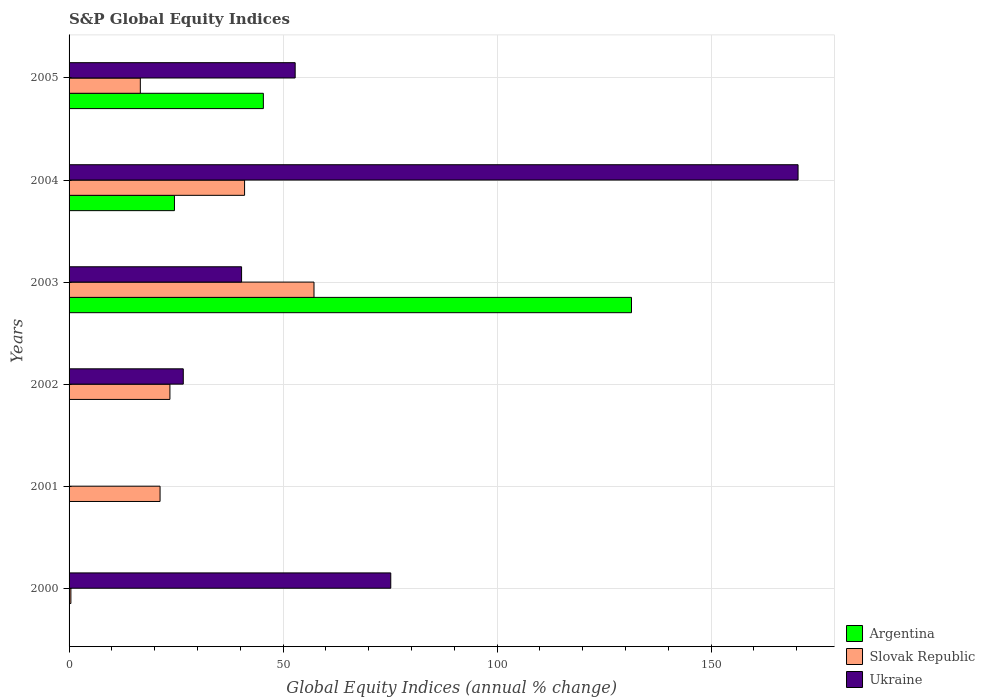How many different coloured bars are there?
Provide a succinct answer. 3. Are the number of bars on each tick of the Y-axis equal?
Offer a terse response. No. How many bars are there on the 5th tick from the top?
Your answer should be very brief. 1. In how many cases, is the number of bars for a given year not equal to the number of legend labels?
Your response must be concise. 3. What is the global equity indices in Ukraine in 2005?
Your answer should be very brief. 52.82. Across all years, what is the maximum global equity indices in Argentina?
Make the answer very short. 131.39. Across all years, what is the minimum global equity indices in Argentina?
Give a very brief answer. 0. In which year was the global equity indices in Slovak Republic maximum?
Provide a short and direct response. 2003. What is the total global equity indices in Ukraine in the graph?
Offer a terse response. 365.25. What is the difference between the global equity indices in Ukraine in 2004 and that in 2005?
Your response must be concise. 117.48. What is the difference between the global equity indices in Ukraine in 2005 and the global equity indices in Slovak Republic in 2002?
Your answer should be compact. 29.26. What is the average global equity indices in Argentina per year?
Keep it short and to the point. 33.57. In the year 2002, what is the difference between the global equity indices in Slovak Republic and global equity indices in Ukraine?
Offer a very short reply. -3.12. What is the ratio of the global equity indices in Ukraine in 2000 to that in 2005?
Keep it short and to the point. 1.42. Is the global equity indices in Ukraine in 2002 less than that in 2004?
Make the answer very short. Yes. What is the difference between the highest and the second highest global equity indices in Slovak Republic?
Offer a very short reply. 16.22. What is the difference between the highest and the lowest global equity indices in Argentina?
Give a very brief answer. 131.39. Is it the case that in every year, the sum of the global equity indices in Slovak Republic and global equity indices in Argentina is greater than the global equity indices in Ukraine?
Provide a short and direct response. No. How many bars are there?
Offer a terse response. 14. Are all the bars in the graph horizontal?
Provide a succinct answer. Yes. How many years are there in the graph?
Provide a short and direct response. 6. Does the graph contain grids?
Your answer should be very brief. Yes. Where does the legend appear in the graph?
Your answer should be compact. Bottom right. What is the title of the graph?
Offer a terse response. S&P Global Equity Indices. What is the label or title of the X-axis?
Keep it short and to the point. Global Equity Indices (annual % change). What is the label or title of the Y-axis?
Provide a succinct answer. Years. What is the Global Equity Indices (annual % change) in Slovak Republic in 2000?
Ensure brevity in your answer.  0.42. What is the Global Equity Indices (annual % change) in Ukraine in 2000?
Your answer should be compact. 75.15. What is the Global Equity Indices (annual % change) of Argentina in 2001?
Make the answer very short. 0. What is the Global Equity Indices (annual % change) of Slovak Republic in 2001?
Make the answer very short. 21.26. What is the Global Equity Indices (annual % change) in Ukraine in 2001?
Keep it short and to the point. 0. What is the Global Equity Indices (annual % change) in Argentina in 2002?
Your answer should be compact. 0. What is the Global Equity Indices (annual % change) in Slovak Republic in 2002?
Give a very brief answer. 23.56. What is the Global Equity Indices (annual % change) of Ukraine in 2002?
Your response must be concise. 26.68. What is the Global Equity Indices (annual % change) of Argentina in 2003?
Make the answer very short. 131.39. What is the Global Equity Indices (annual % change) in Slovak Republic in 2003?
Offer a very short reply. 57.22. What is the Global Equity Indices (annual % change) of Ukraine in 2003?
Provide a succinct answer. 40.3. What is the Global Equity Indices (annual % change) of Argentina in 2004?
Offer a very short reply. 24.62. What is the Global Equity Indices (annual % change) of Ukraine in 2004?
Your response must be concise. 170.3. What is the Global Equity Indices (annual % change) of Argentina in 2005?
Ensure brevity in your answer.  45.39. What is the Global Equity Indices (annual % change) of Slovak Republic in 2005?
Offer a very short reply. 16.65. What is the Global Equity Indices (annual % change) in Ukraine in 2005?
Your answer should be very brief. 52.82. Across all years, what is the maximum Global Equity Indices (annual % change) of Argentina?
Keep it short and to the point. 131.39. Across all years, what is the maximum Global Equity Indices (annual % change) in Slovak Republic?
Your response must be concise. 57.22. Across all years, what is the maximum Global Equity Indices (annual % change) in Ukraine?
Provide a succinct answer. 170.3. Across all years, what is the minimum Global Equity Indices (annual % change) of Argentina?
Offer a terse response. 0. Across all years, what is the minimum Global Equity Indices (annual % change) in Slovak Republic?
Your answer should be very brief. 0.42. Across all years, what is the minimum Global Equity Indices (annual % change) in Ukraine?
Give a very brief answer. 0. What is the total Global Equity Indices (annual % change) of Argentina in the graph?
Your answer should be compact. 201.4. What is the total Global Equity Indices (annual % change) of Slovak Republic in the graph?
Provide a succinct answer. 160.11. What is the total Global Equity Indices (annual % change) in Ukraine in the graph?
Your answer should be very brief. 365.25. What is the difference between the Global Equity Indices (annual % change) of Slovak Republic in 2000 and that in 2001?
Offer a terse response. -20.83. What is the difference between the Global Equity Indices (annual % change) in Slovak Republic in 2000 and that in 2002?
Offer a very short reply. -23.14. What is the difference between the Global Equity Indices (annual % change) of Ukraine in 2000 and that in 2002?
Your response must be concise. 48.47. What is the difference between the Global Equity Indices (annual % change) of Slovak Republic in 2000 and that in 2003?
Ensure brevity in your answer.  -56.8. What is the difference between the Global Equity Indices (annual % change) of Ukraine in 2000 and that in 2003?
Your response must be concise. 34.85. What is the difference between the Global Equity Indices (annual % change) of Slovak Republic in 2000 and that in 2004?
Your answer should be very brief. -40.58. What is the difference between the Global Equity Indices (annual % change) of Ukraine in 2000 and that in 2004?
Provide a succinct answer. -95.15. What is the difference between the Global Equity Indices (annual % change) of Slovak Republic in 2000 and that in 2005?
Offer a terse response. -16.22. What is the difference between the Global Equity Indices (annual % change) of Ukraine in 2000 and that in 2005?
Your answer should be very brief. 22.33. What is the difference between the Global Equity Indices (annual % change) in Slovak Republic in 2001 and that in 2002?
Keep it short and to the point. -2.3. What is the difference between the Global Equity Indices (annual % change) of Slovak Republic in 2001 and that in 2003?
Provide a succinct answer. -35.96. What is the difference between the Global Equity Indices (annual % change) of Slovak Republic in 2001 and that in 2004?
Offer a terse response. -19.74. What is the difference between the Global Equity Indices (annual % change) in Slovak Republic in 2001 and that in 2005?
Give a very brief answer. 4.61. What is the difference between the Global Equity Indices (annual % change) of Slovak Republic in 2002 and that in 2003?
Provide a succinct answer. -33.66. What is the difference between the Global Equity Indices (annual % change) in Ukraine in 2002 and that in 2003?
Your answer should be very brief. -13.62. What is the difference between the Global Equity Indices (annual % change) in Slovak Republic in 2002 and that in 2004?
Ensure brevity in your answer.  -17.44. What is the difference between the Global Equity Indices (annual % change) in Ukraine in 2002 and that in 2004?
Your response must be concise. -143.62. What is the difference between the Global Equity Indices (annual % change) of Slovak Republic in 2002 and that in 2005?
Ensure brevity in your answer.  6.91. What is the difference between the Global Equity Indices (annual % change) in Ukraine in 2002 and that in 2005?
Keep it short and to the point. -26.14. What is the difference between the Global Equity Indices (annual % change) of Argentina in 2003 and that in 2004?
Keep it short and to the point. 106.77. What is the difference between the Global Equity Indices (annual % change) of Slovak Republic in 2003 and that in 2004?
Ensure brevity in your answer.  16.22. What is the difference between the Global Equity Indices (annual % change) of Ukraine in 2003 and that in 2004?
Your answer should be compact. -130. What is the difference between the Global Equity Indices (annual % change) in Argentina in 2003 and that in 2005?
Ensure brevity in your answer.  86. What is the difference between the Global Equity Indices (annual % change) of Slovak Republic in 2003 and that in 2005?
Your response must be concise. 40.57. What is the difference between the Global Equity Indices (annual % change) in Ukraine in 2003 and that in 2005?
Give a very brief answer. -12.52. What is the difference between the Global Equity Indices (annual % change) in Argentina in 2004 and that in 2005?
Provide a succinct answer. -20.77. What is the difference between the Global Equity Indices (annual % change) in Slovak Republic in 2004 and that in 2005?
Provide a short and direct response. 24.35. What is the difference between the Global Equity Indices (annual % change) of Ukraine in 2004 and that in 2005?
Make the answer very short. 117.48. What is the difference between the Global Equity Indices (annual % change) of Slovak Republic in 2000 and the Global Equity Indices (annual % change) of Ukraine in 2002?
Keep it short and to the point. -26.26. What is the difference between the Global Equity Indices (annual % change) in Slovak Republic in 2000 and the Global Equity Indices (annual % change) in Ukraine in 2003?
Offer a very short reply. -39.88. What is the difference between the Global Equity Indices (annual % change) of Slovak Republic in 2000 and the Global Equity Indices (annual % change) of Ukraine in 2004?
Ensure brevity in your answer.  -169.88. What is the difference between the Global Equity Indices (annual % change) in Slovak Republic in 2000 and the Global Equity Indices (annual % change) in Ukraine in 2005?
Your response must be concise. -52.4. What is the difference between the Global Equity Indices (annual % change) of Slovak Republic in 2001 and the Global Equity Indices (annual % change) of Ukraine in 2002?
Make the answer very short. -5.42. What is the difference between the Global Equity Indices (annual % change) in Slovak Republic in 2001 and the Global Equity Indices (annual % change) in Ukraine in 2003?
Your response must be concise. -19.04. What is the difference between the Global Equity Indices (annual % change) in Slovak Republic in 2001 and the Global Equity Indices (annual % change) in Ukraine in 2004?
Keep it short and to the point. -149.04. What is the difference between the Global Equity Indices (annual % change) in Slovak Republic in 2001 and the Global Equity Indices (annual % change) in Ukraine in 2005?
Ensure brevity in your answer.  -31.56. What is the difference between the Global Equity Indices (annual % change) in Slovak Republic in 2002 and the Global Equity Indices (annual % change) in Ukraine in 2003?
Your response must be concise. -16.74. What is the difference between the Global Equity Indices (annual % change) in Slovak Republic in 2002 and the Global Equity Indices (annual % change) in Ukraine in 2004?
Make the answer very short. -146.74. What is the difference between the Global Equity Indices (annual % change) in Slovak Republic in 2002 and the Global Equity Indices (annual % change) in Ukraine in 2005?
Give a very brief answer. -29.26. What is the difference between the Global Equity Indices (annual % change) in Argentina in 2003 and the Global Equity Indices (annual % change) in Slovak Republic in 2004?
Keep it short and to the point. 90.39. What is the difference between the Global Equity Indices (annual % change) of Argentina in 2003 and the Global Equity Indices (annual % change) of Ukraine in 2004?
Give a very brief answer. -38.91. What is the difference between the Global Equity Indices (annual % change) of Slovak Republic in 2003 and the Global Equity Indices (annual % change) of Ukraine in 2004?
Provide a succinct answer. -113.08. What is the difference between the Global Equity Indices (annual % change) in Argentina in 2003 and the Global Equity Indices (annual % change) in Slovak Republic in 2005?
Give a very brief answer. 114.74. What is the difference between the Global Equity Indices (annual % change) of Argentina in 2003 and the Global Equity Indices (annual % change) of Ukraine in 2005?
Your answer should be compact. 78.57. What is the difference between the Global Equity Indices (annual % change) in Slovak Republic in 2003 and the Global Equity Indices (annual % change) in Ukraine in 2005?
Your answer should be compact. 4.4. What is the difference between the Global Equity Indices (annual % change) of Argentina in 2004 and the Global Equity Indices (annual % change) of Slovak Republic in 2005?
Give a very brief answer. 7.97. What is the difference between the Global Equity Indices (annual % change) in Argentina in 2004 and the Global Equity Indices (annual % change) in Ukraine in 2005?
Offer a terse response. -28.2. What is the difference between the Global Equity Indices (annual % change) in Slovak Republic in 2004 and the Global Equity Indices (annual % change) in Ukraine in 2005?
Make the answer very short. -11.82. What is the average Global Equity Indices (annual % change) in Argentina per year?
Your answer should be compact. 33.57. What is the average Global Equity Indices (annual % change) in Slovak Republic per year?
Your answer should be very brief. 26.68. What is the average Global Equity Indices (annual % change) of Ukraine per year?
Give a very brief answer. 60.88. In the year 2000, what is the difference between the Global Equity Indices (annual % change) of Slovak Republic and Global Equity Indices (annual % change) of Ukraine?
Keep it short and to the point. -74.73. In the year 2002, what is the difference between the Global Equity Indices (annual % change) in Slovak Republic and Global Equity Indices (annual % change) in Ukraine?
Offer a very short reply. -3.12. In the year 2003, what is the difference between the Global Equity Indices (annual % change) of Argentina and Global Equity Indices (annual % change) of Slovak Republic?
Offer a terse response. 74.17. In the year 2003, what is the difference between the Global Equity Indices (annual % change) of Argentina and Global Equity Indices (annual % change) of Ukraine?
Make the answer very short. 91.09. In the year 2003, what is the difference between the Global Equity Indices (annual % change) in Slovak Republic and Global Equity Indices (annual % change) in Ukraine?
Provide a short and direct response. 16.92. In the year 2004, what is the difference between the Global Equity Indices (annual % change) of Argentina and Global Equity Indices (annual % change) of Slovak Republic?
Offer a terse response. -16.38. In the year 2004, what is the difference between the Global Equity Indices (annual % change) in Argentina and Global Equity Indices (annual % change) in Ukraine?
Give a very brief answer. -145.68. In the year 2004, what is the difference between the Global Equity Indices (annual % change) of Slovak Republic and Global Equity Indices (annual % change) of Ukraine?
Make the answer very short. -129.3. In the year 2005, what is the difference between the Global Equity Indices (annual % change) in Argentina and Global Equity Indices (annual % change) in Slovak Republic?
Make the answer very short. 28.74. In the year 2005, what is the difference between the Global Equity Indices (annual % change) in Argentina and Global Equity Indices (annual % change) in Ukraine?
Give a very brief answer. -7.43. In the year 2005, what is the difference between the Global Equity Indices (annual % change) in Slovak Republic and Global Equity Indices (annual % change) in Ukraine?
Give a very brief answer. -36.17. What is the ratio of the Global Equity Indices (annual % change) of Slovak Republic in 2000 to that in 2001?
Provide a short and direct response. 0.02. What is the ratio of the Global Equity Indices (annual % change) of Slovak Republic in 2000 to that in 2002?
Provide a succinct answer. 0.02. What is the ratio of the Global Equity Indices (annual % change) in Ukraine in 2000 to that in 2002?
Your answer should be very brief. 2.82. What is the ratio of the Global Equity Indices (annual % change) in Slovak Republic in 2000 to that in 2003?
Your answer should be very brief. 0.01. What is the ratio of the Global Equity Indices (annual % change) in Ukraine in 2000 to that in 2003?
Offer a terse response. 1.86. What is the ratio of the Global Equity Indices (annual % change) in Slovak Republic in 2000 to that in 2004?
Provide a short and direct response. 0.01. What is the ratio of the Global Equity Indices (annual % change) in Ukraine in 2000 to that in 2004?
Your answer should be very brief. 0.44. What is the ratio of the Global Equity Indices (annual % change) in Slovak Republic in 2000 to that in 2005?
Ensure brevity in your answer.  0.03. What is the ratio of the Global Equity Indices (annual % change) of Ukraine in 2000 to that in 2005?
Offer a terse response. 1.42. What is the ratio of the Global Equity Indices (annual % change) of Slovak Republic in 2001 to that in 2002?
Offer a terse response. 0.9. What is the ratio of the Global Equity Indices (annual % change) in Slovak Republic in 2001 to that in 2003?
Your answer should be very brief. 0.37. What is the ratio of the Global Equity Indices (annual % change) in Slovak Republic in 2001 to that in 2004?
Give a very brief answer. 0.52. What is the ratio of the Global Equity Indices (annual % change) of Slovak Republic in 2001 to that in 2005?
Your answer should be very brief. 1.28. What is the ratio of the Global Equity Indices (annual % change) in Slovak Republic in 2002 to that in 2003?
Give a very brief answer. 0.41. What is the ratio of the Global Equity Indices (annual % change) in Ukraine in 2002 to that in 2003?
Provide a succinct answer. 0.66. What is the ratio of the Global Equity Indices (annual % change) in Slovak Republic in 2002 to that in 2004?
Give a very brief answer. 0.57. What is the ratio of the Global Equity Indices (annual % change) of Ukraine in 2002 to that in 2004?
Give a very brief answer. 0.16. What is the ratio of the Global Equity Indices (annual % change) of Slovak Republic in 2002 to that in 2005?
Your answer should be compact. 1.42. What is the ratio of the Global Equity Indices (annual % change) in Ukraine in 2002 to that in 2005?
Ensure brevity in your answer.  0.51. What is the ratio of the Global Equity Indices (annual % change) of Argentina in 2003 to that in 2004?
Ensure brevity in your answer.  5.34. What is the ratio of the Global Equity Indices (annual % change) of Slovak Republic in 2003 to that in 2004?
Provide a short and direct response. 1.4. What is the ratio of the Global Equity Indices (annual % change) in Ukraine in 2003 to that in 2004?
Your answer should be very brief. 0.24. What is the ratio of the Global Equity Indices (annual % change) of Argentina in 2003 to that in 2005?
Provide a short and direct response. 2.89. What is the ratio of the Global Equity Indices (annual % change) in Slovak Republic in 2003 to that in 2005?
Your answer should be compact. 3.44. What is the ratio of the Global Equity Indices (annual % change) of Ukraine in 2003 to that in 2005?
Provide a succinct answer. 0.76. What is the ratio of the Global Equity Indices (annual % change) of Argentina in 2004 to that in 2005?
Your response must be concise. 0.54. What is the ratio of the Global Equity Indices (annual % change) in Slovak Republic in 2004 to that in 2005?
Make the answer very short. 2.46. What is the ratio of the Global Equity Indices (annual % change) of Ukraine in 2004 to that in 2005?
Offer a very short reply. 3.22. What is the difference between the highest and the second highest Global Equity Indices (annual % change) in Argentina?
Provide a succinct answer. 86. What is the difference between the highest and the second highest Global Equity Indices (annual % change) of Slovak Republic?
Keep it short and to the point. 16.22. What is the difference between the highest and the second highest Global Equity Indices (annual % change) of Ukraine?
Keep it short and to the point. 95.15. What is the difference between the highest and the lowest Global Equity Indices (annual % change) of Argentina?
Ensure brevity in your answer.  131.39. What is the difference between the highest and the lowest Global Equity Indices (annual % change) of Slovak Republic?
Provide a short and direct response. 56.8. What is the difference between the highest and the lowest Global Equity Indices (annual % change) in Ukraine?
Your answer should be very brief. 170.3. 